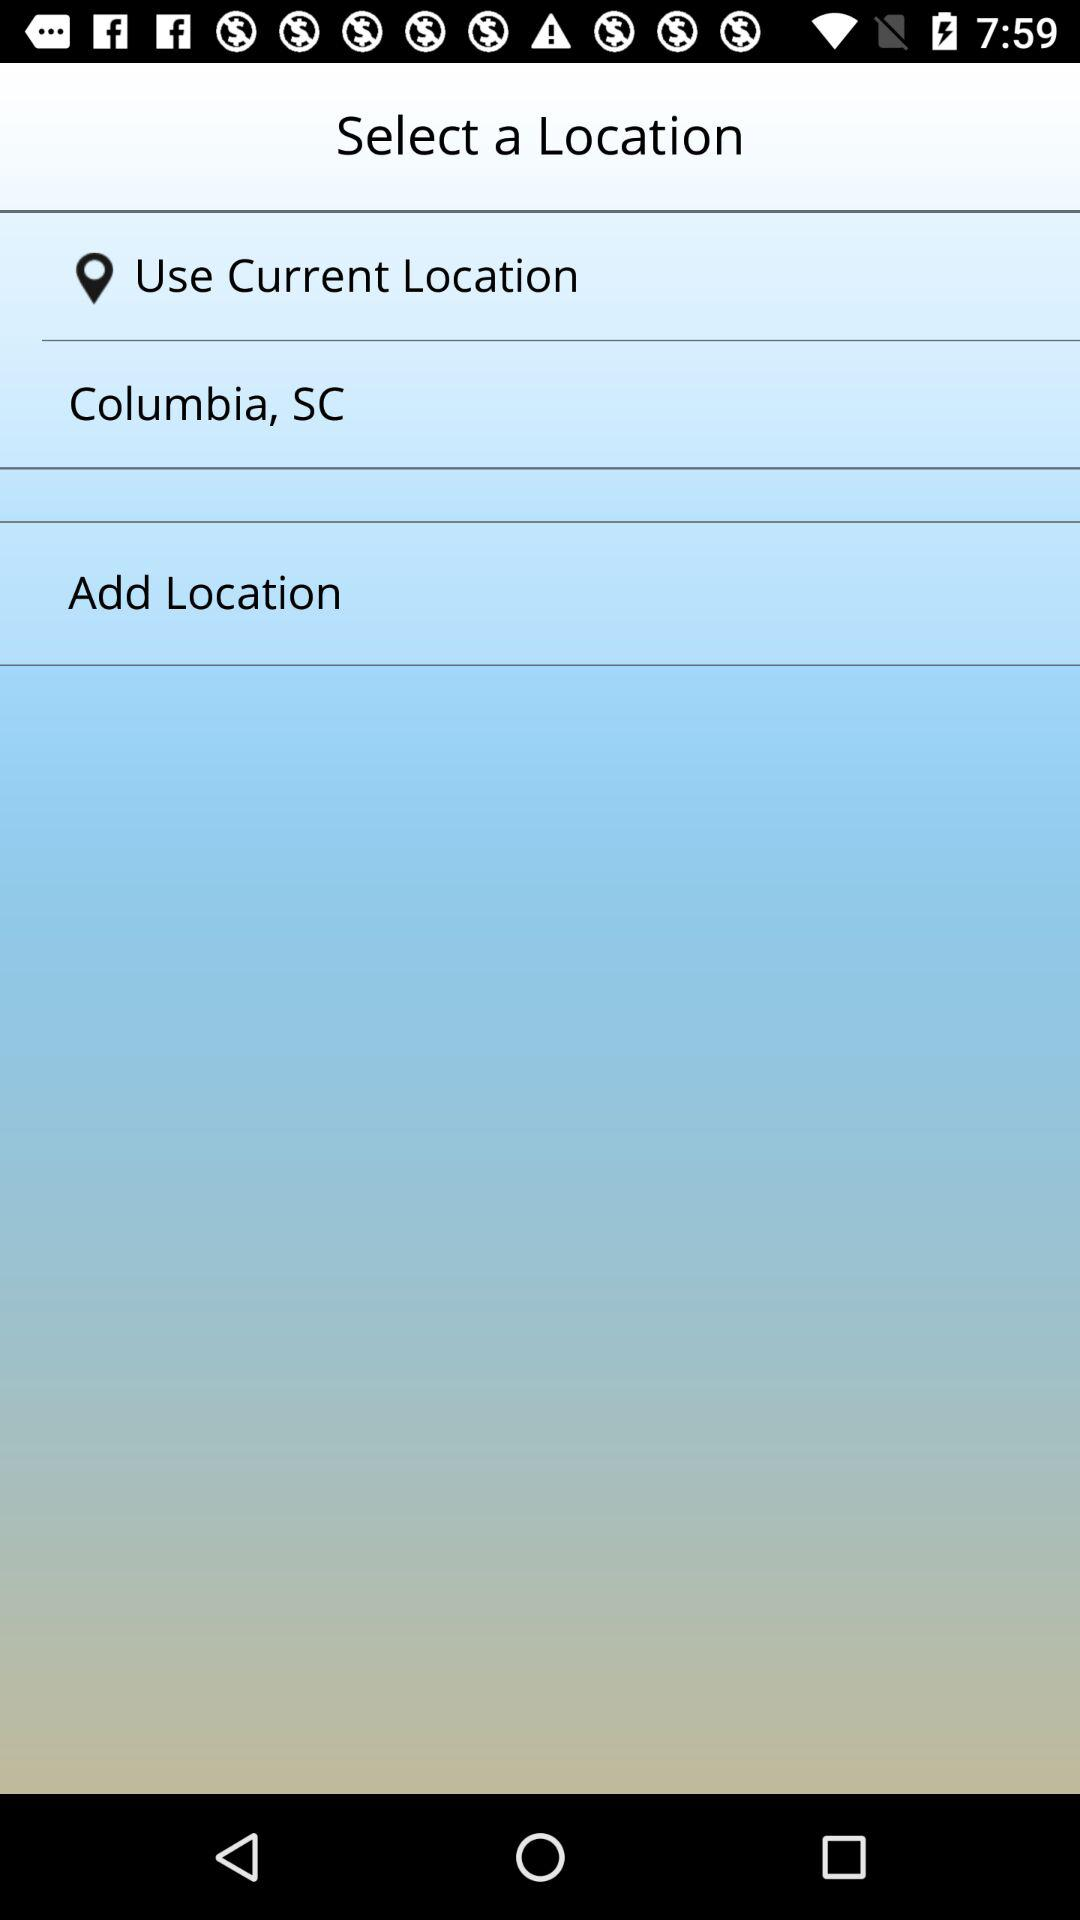What is the mentioned location? The mentioned location is Columbia, SC. 